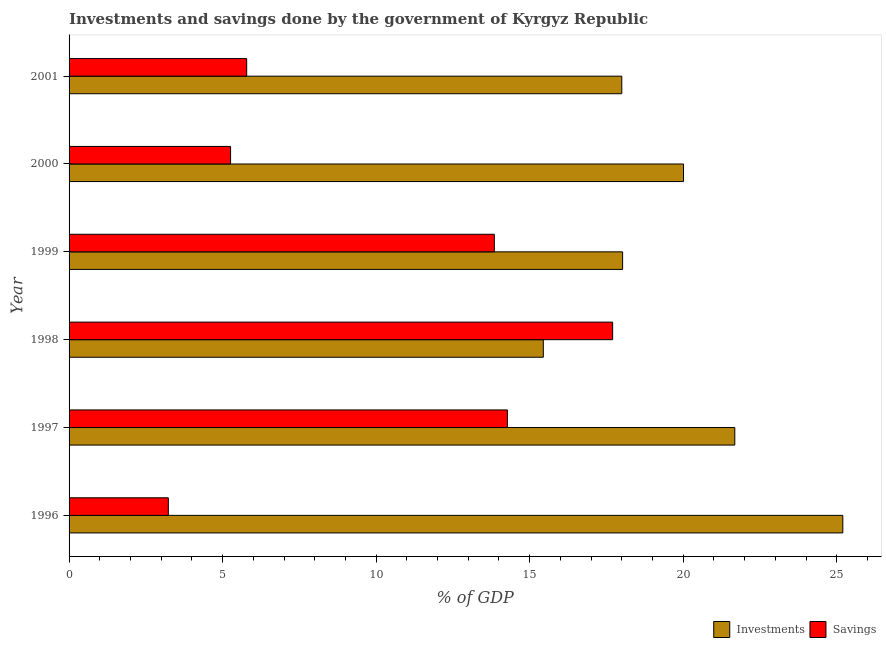How many groups of bars are there?
Keep it short and to the point. 6. Are the number of bars per tick equal to the number of legend labels?
Your answer should be very brief. Yes. Are the number of bars on each tick of the Y-axis equal?
Give a very brief answer. Yes. How many bars are there on the 6th tick from the bottom?
Ensure brevity in your answer.  2. What is the investments of government in 1997?
Offer a very short reply. 21.68. Across all years, what is the maximum investments of government?
Keep it short and to the point. 25.2. Across all years, what is the minimum savings of government?
Provide a succinct answer. 3.23. In which year was the investments of government maximum?
Offer a terse response. 1996. In which year was the investments of government minimum?
Your response must be concise. 1998. What is the total savings of government in the graph?
Keep it short and to the point. 60.1. What is the difference between the savings of government in 1996 and that in 2001?
Offer a terse response. -2.55. What is the difference between the investments of government in 1997 and the savings of government in 2001?
Offer a very short reply. 15.9. What is the average savings of government per year?
Your answer should be compact. 10.02. In the year 1997, what is the difference between the savings of government and investments of government?
Provide a succinct answer. -7.41. In how many years, is the investments of government greater than 13 %?
Your answer should be compact. 6. What is the ratio of the savings of government in 1998 to that in 2000?
Offer a very short reply. 3.37. What is the difference between the highest and the second highest savings of government?
Keep it short and to the point. 3.43. What is the difference between the highest and the lowest savings of government?
Your answer should be compact. 14.47. In how many years, is the investments of government greater than the average investments of government taken over all years?
Your answer should be compact. 3. What does the 1st bar from the top in 2001 represents?
Your response must be concise. Savings. What does the 2nd bar from the bottom in 1998 represents?
Your answer should be compact. Savings. How many bars are there?
Provide a succinct answer. 12. How many years are there in the graph?
Give a very brief answer. 6. What is the difference between two consecutive major ticks on the X-axis?
Ensure brevity in your answer.  5. Are the values on the major ticks of X-axis written in scientific E-notation?
Give a very brief answer. No. Does the graph contain any zero values?
Provide a succinct answer. No. How many legend labels are there?
Ensure brevity in your answer.  2. What is the title of the graph?
Provide a short and direct response. Investments and savings done by the government of Kyrgyz Republic. Does "International Tourists" appear as one of the legend labels in the graph?
Keep it short and to the point. No. What is the label or title of the X-axis?
Provide a succinct answer. % of GDP. What is the % of GDP of Investments in 1996?
Your response must be concise. 25.2. What is the % of GDP of Savings in 1996?
Your answer should be very brief. 3.23. What is the % of GDP in Investments in 1997?
Your response must be concise. 21.68. What is the % of GDP of Savings in 1997?
Your response must be concise. 14.27. What is the % of GDP in Investments in 1998?
Ensure brevity in your answer.  15.44. What is the % of GDP in Savings in 1998?
Your answer should be very brief. 17.7. What is the % of GDP in Investments in 1999?
Provide a succinct answer. 18.03. What is the % of GDP in Savings in 1999?
Give a very brief answer. 13.85. What is the % of GDP of Investments in 2000?
Keep it short and to the point. 20.01. What is the % of GDP in Savings in 2000?
Provide a succinct answer. 5.26. What is the % of GDP in Investments in 2001?
Provide a succinct answer. 18. What is the % of GDP of Savings in 2001?
Your answer should be very brief. 5.78. Across all years, what is the maximum % of GDP in Investments?
Give a very brief answer. 25.2. Across all years, what is the maximum % of GDP of Savings?
Offer a very short reply. 17.7. Across all years, what is the minimum % of GDP of Investments?
Give a very brief answer. 15.44. Across all years, what is the minimum % of GDP of Savings?
Offer a very short reply. 3.23. What is the total % of GDP of Investments in the graph?
Your answer should be very brief. 118.36. What is the total % of GDP in Savings in the graph?
Provide a succinct answer. 60.1. What is the difference between the % of GDP in Investments in 1996 and that in 1997?
Your response must be concise. 3.52. What is the difference between the % of GDP of Savings in 1996 and that in 1997?
Make the answer very short. -11.04. What is the difference between the % of GDP in Investments in 1996 and that in 1998?
Ensure brevity in your answer.  9.75. What is the difference between the % of GDP in Savings in 1996 and that in 1998?
Ensure brevity in your answer.  -14.47. What is the difference between the % of GDP in Investments in 1996 and that in 1999?
Offer a very short reply. 7.17. What is the difference between the % of GDP of Savings in 1996 and that in 1999?
Offer a very short reply. -10.62. What is the difference between the % of GDP in Investments in 1996 and that in 2000?
Your response must be concise. 5.19. What is the difference between the % of GDP of Savings in 1996 and that in 2000?
Provide a short and direct response. -2.03. What is the difference between the % of GDP in Investments in 1996 and that in 2001?
Your response must be concise. 7.2. What is the difference between the % of GDP in Savings in 1996 and that in 2001?
Offer a terse response. -2.55. What is the difference between the % of GDP of Investments in 1997 and that in 1998?
Your response must be concise. 6.24. What is the difference between the % of GDP of Savings in 1997 and that in 1998?
Ensure brevity in your answer.  -3.43. What is the difference between the % of GDP in Investments in 1997 and that in 1999?
Your response must be concise. 3.65. What is the difference between the % of GDP of Savings in 1997 and that in 1999?
Your response must be concise. 0.43. What is the difference between the % of GDP in Investments in 1997 and that in 2000?
Ensure brevity in your answer.  1.67. What is the difference between the % of GDP of Savings in 1997 and that in 2000?
Your answer should be compact. 9.02. What is the difference between the % of GDP in Investments in 1997 and that in 2001?
Provide a short and direct response. 3.68. What is the difference between the % of GDP in Savings in 1997 and that in 2001?
Your response must be concise. 8.49. What is the difference between the % of GDP in Investments in 1998 and that in 1999?
Your answer should be compact. -2.58. What is the difference between the % of GDP in Savings in 1998 and that in 1999?
Your answer should be very brief. 3.85. What is the difference between the % of GDP in Investments in 1998 and that in 2000?
Offer a terse response. -4.57. What is the difference between the % of GDP in Savings in 1998 and that in 2000?
Your answer should be very brief. 12.44. What is the difference between the % of GDP of Investments in 1998 and that in 2001?
Ensure brevity in your answer.  -2.56. What is the difference between the % of GDP of Savings in 1998 and that in 2001?
Ensure brevity in your answer.  11.92. What is the difference between the % of GDP in Investments in 1999 and that in 2000?
Your response must be concise. -1.98. What is the difference between the % of GDP of Savings in 1999 and that in 2000?
Offer a terse response. 8.59. What is the difference between the % of GDP of Investments in 1999 and that in 2001?
Give a very brief answer. 0.03. What is the difference between the % of GDP in Savings in 1999 and that in 2001?
Provide a short and direct response. 8.06. What is the difference between the % of GDP of Investments in 2000 and that in 2001?
Your answer should be very brief. 2.01. What is the difference between the % of GDP of Savings in 2000 and that in 2001?
Offer a very short reply. -0.53. What is the difference between the % of GDP in Investments in 1996 and the % of GDP in Savings in 1997?
Your answer should be compact. 10.92. What is the difference between the % of GDP of Investments in 1996 and the % of GDP of Savings in 1998?
Make the answer very short. 7.5. What is the difference between the % of GDP of Investments in 1996 and the % of GDP of Savings in 1999?
Make the answer very short. 11.35. What is the difference between the % of GDP in Investments in 1996 and the % of GDP in Savings in 2000?
Make the answer very short. 19.94. What is the difference between the % of GDP of Investments in 1996 and the % of GDP of Savings in 2001?
Your response must be concise. 19.41. What is the difference between the % of GDP in Investments in 1997 and the % of GDP in Savings in 1998?
Your answer should be compact. 3.98. What is the difference between the % of GDP of Investments in 1997 and the % of GDP of Savings in 1999?
Your response must be concise. 7.83. What is the difference between the % of GDP in Investments in 1997 and the % of GDP in Savings in 2000?
Provide a succinct answer. 16.42. What is the difference between the % of GDP of Investments in 1997 and the % of GDP of Savings in 2001?
Offer a very short reply. 15.9. What is the difference between the % of GDP in Investments in 1998 and the % of GDP in Savings in 1999?
Make the answer very short. 1.6. What is the difference between the % of GDP in Investments in 1998 and the % of GDP in Savings in 2000?
Keep it short and to the point. 10.18. What is the difference between the % of GDP of Investments in 1998 and the % of GDP of Savings in 2001?
Make the answer very short. 9.66. What is the difference between the % of GDP of Investments in 1999 and the % of GDP of Savings in 2000?
Your answer should be compact. 12.77. What is the difference between the % of GDP of Investments in 1999 and the % of GDP of Savings in 2001?
Your answer should be compact. 12.24. What is the difference between the % of GDP in Investments in 2000 and the % of GDP in Savings in 2001?
Ensure brevity in your answer.  14.23. What is the average % of GDP in Investments per year?
Ensure brevity in your answer.  19.73. What is the average % of GDP of Savings per year?
Give a very brief answer. 10.02. In the year 1996, what is the difference between the % of GDP in Investments and % of GDP in Savings?
Offer a very short reply. 21.96. In the year 1997, what is the difference between the % of GDP of Investments and % of GDP of Savings?
Ensure brevity in your answer.  7.41. In the year 1998, what is the difference between the % of GDP in Investments and % of GDP in Savings?
Your answer should be compact. -2.26. In the year 1999, what is the difference between the % of GDP of Investments and % of GDP of Savings?
Offer a very short reply. 4.18. In the year 2000, what is the difference between the % of GDP in Investments and % of GDP in Savings?
Make the answer very short. 14.75. In the year 2001, what is the difference between the % of GDP in Investments and % of GDP in Savings?
Give a very brief answer. 12.21. What is the ratio of the % of GDP in Investments in 1996 to that in 1997?
Your answer should be very brief. 1.16. What is the ratio of the % of GDP of Savings in 1996 to that in 1997?
Ensure brevity in your answer.  0.23. What is the ratio of the % of GDP in Investments in 1996 to that in 1998?
Ensure brevity in your answer.  1.63. What is the ratio of the % of GDP in Savings in 1996 to that in 1998?
Offer a very short reply. 0.18. What is the ratio of the % of GDP of Investments in 1996 to that in 1999?
Make the answer very short. 1.4. What is the ratio of the % of GDP of Savings in 1996 to that in 1999?
Keep it short and to the point. 0.23. What is the ratio of the % of GDP in Investments in 1996 to that in 2000?
Provide a short and direct response. 1.26. What is the ratio of the % of GDP of Savings in 1996 to that in 2000?
Your answer should be very brief. 0.61. What is the ratio of the % of GDP in Investments in 1996 to that in 2001?
Provide a succinct answer. 1.4. What is the ratio of the % of GDP in Savings in 1996 to that in 2001?
Provide a short and direct response. 0.56. What is the ratio of the % of GDP of Investments in 1997 to that in 1998?
Provide a short and direct response. 1.4. What is the ratio of the % of GDP of Savings in 1997 to that in 1998?
Provide a succinct answer. 0.81. What is the ratio of the % of GDP in Investments in 1997 to that in 1999?
Make the answer very short. 1.2. What is the ratio of the % of GDP in Savings in 1997 to that in 1999?
Your answer should be compact. 1.03. What is the ratio of the % of GDP of Investments in 1997 to that in 2000?
Your response must be concise. 1.08. What is the ratio of the % of GDP of Savings in 1997 to that in 2000?
Your answer should be compact. 2.71. What is the ratio of the % of GDP of Investments in 1997 to that in 2001?
Give a very brief answer. 1.2. What is the ratio of the % of GDP in Savings in 1997 to that in 2001?
Keep it short and to the point. 2.47. What is the ratio of the % of GDP of Investments in 1998 to that in 1999?
Provide a short and direct response. 0.86. What is the ratio of the % of GDP of Savings in 1998 to that in 1999?
Keep it short and to the point. 1.28. What is the ratio of the % of GDP of Investments in 1998 to that in 2000?
Provide a short and direct response. 0.77. What is the ratio of the % of GDP of Savings in 1998 to that in 2000?
Provide a succinct answer. 3.37. What is the ratio of the % of GDP of Investments in 1998 to that in 2001?
Your answer should be compact. 0.86. What is the ratio of the % of GDP in Savings in 1998 to that in 2001?
Provide a short and direct response. 3.06. What is the ratio of the % of GDP of Investments in 1999 to that in 2000?
Your answer should be very brief. 0.9. What is the ratio of the % of GDP of Savings in 1999 to that in 2000?
Provide a short and direct response. 2.63. What is the ratio of the % of GDP of Savings in 1999 to that in 2001?
Your answer should be compact. 2.39. What is the ratio of the % of GDP of Investments in 2000 to that in 2001?
Ensure brevity in your answer.  1.11. What is the ratio of the % of GDP of Savings in 2000 to that in 2001?
Provide a succinct answer. 0.91. What is the difference between the highest and the second highest % of GDP of Investments?
Provide a succinct answer. 3.52. What is the difference between the highest and the second highest % of GDP of Savings?
Offer a terse response. 3.43. What is the difference between the highest and the lowest % of GDP in Investments?
Your answer should be very brief. 9.75. What is the difference between the highest and the lowest % of GDP in Savings?
Offer a terse response. 14.47. 